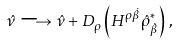<formula> <loc_0><loc_0><loc_500><loc_500>\hat { \nu } \longrightarrow \hat { \nu } + D _ { \rho } \left ( H ^ { \rho \dot { \beta } } \hat { \rho } ^ { * } _ { \dot { \beta } } \right ) \, ,</formula> 